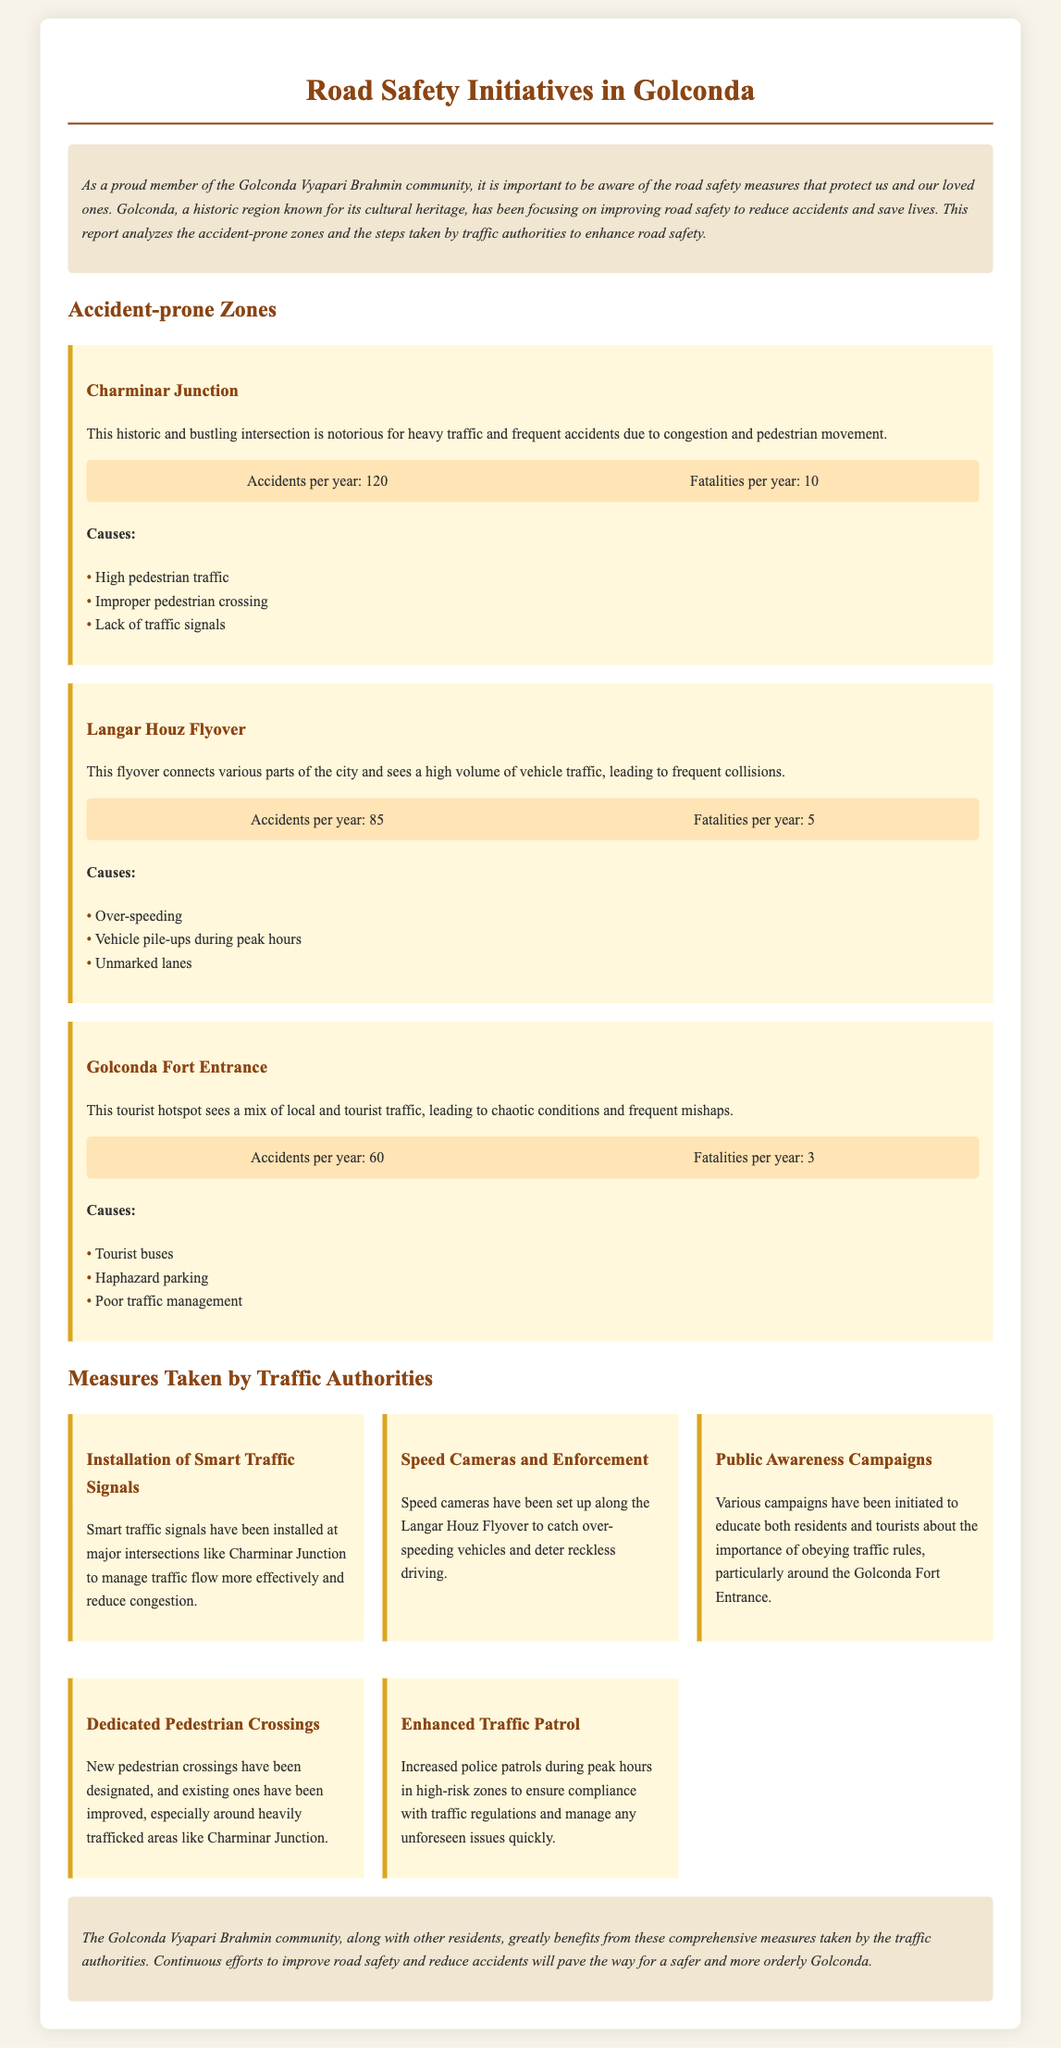What is the number of accidents per year at Charminar Junction? The document states that the number of accidents per year at Charminar Junction is 120.
Answer: 120 How many fatalities occur per year at Langar Houz Flyover? It is noted that there are 5 fatalities per year at Langar Houz Flyover in the document.
Answer: 5 What safety measure has been implemented at Charminar Junction? The document mentions the installation of smart traffic signals as a safety measure at Charminar Junction.
Answer: Smart traffic signals What is a major cause of accidents at the Golconda Fort Entrance? According to the document, a major cause of accidents at the Golconda Fort Entrance is haphazard parking.
Answer: Haphazard parking How many accident-prone zones are identified in the report? The report identifies three accident-prone zones: Charminar Junction, Langar Houz Flyover, and Golconda Fort Entrance.
Answer: Three What type of campaigns have been initiated to promote road safety? The document notes that public awareness campaigns have been initiated to educate residents and tourists about traffic rules.
Answer: Public awareness campaigns What is the number of accidents per year at Golconda Fort Entrance? The accidents per year at Golconda Fort Entrance are stated as 60 in the document.
Answer: 60 What initiative has been taken to improve pedestrian safety around Charminar Junction? The document states that new pedestrian crossings have been designated and existing ones improved in this area.
Answer: New pedestrian crossings How many accidents occur annually at Langar Houz Flyover? It is reported that there are 85 accidents annually at Langar Houz Flyover.
Answer: 85 